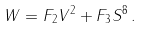Convert formula to latex. <formula><loc_0><loc_0><loc_500><loc_500>W = F _ { 2 } V ^ { 2 } + F _ { 3 } S ^ { 8 } \, .</formula> 